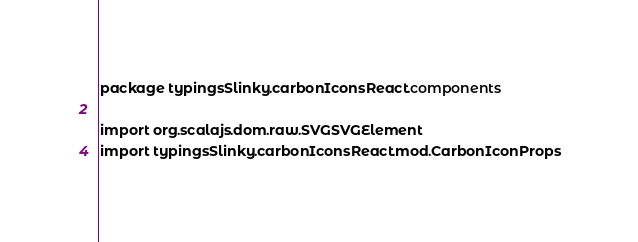Convert code to text. <code><loc_0><loc_0><loc_500><loc_500><_Scala_>package typingsSlinky.carbonIconsReact.components

import org.scalajs.dom.raw.SVGSVGElement
import typingsSlinky.carbonIconsReact.mod.CarbonIconProps</code> 